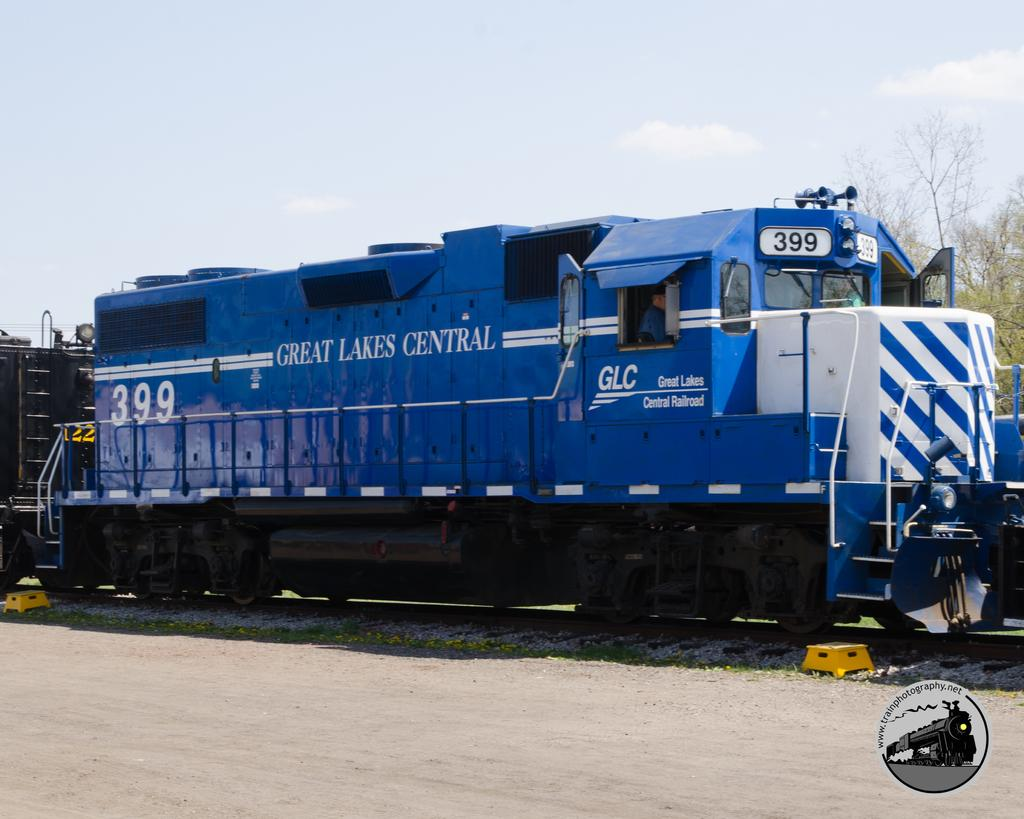What is the main subject of the image? The main subject of the image is a train. What is the train situated on? The train is situated on a railway track. What can be seen in the background of the image? The sky is visible in the image. Where is the rod used for fishing located in the image? There is no rod used for fishing present in the image. Can you tell me how many cars are parked near the train in the image? There is no car present in the image; it only features a train and a railway track. 